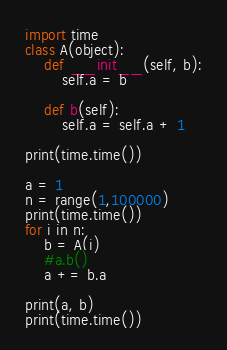Convert code to text. <code><loc_0><loc_0><loc_500><loc_500><_Python_>import time
class A(object):
	def __init__(self, b):
		self.a = b

	def b(self):
		self.a = self.a + 1

print(time.time())

a = 1
n = range(1,100000)
print(time.time())
for i in n:
	b = A(i)
	#a.b()
	a += b.a

print(a, b)
print(time.time())</code> 